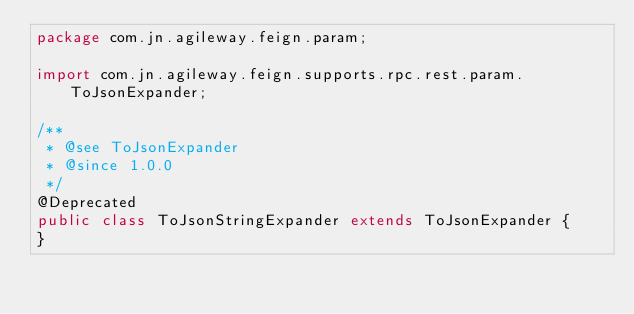Convert code to text. <code><loc_0><loc_0><loc_500><loc_500><_Java_>package com.jn.agileway.feign.param;

import com.jn.agileway.feign.supports.rpc.rest.param.ToJsonExpander;

/**
 * @see ToJsonExpander
 * @since 1.0.0
 */
@Deprecated
public class ToJsonStringExpander extends ToJsonExpander {
}
</code> 